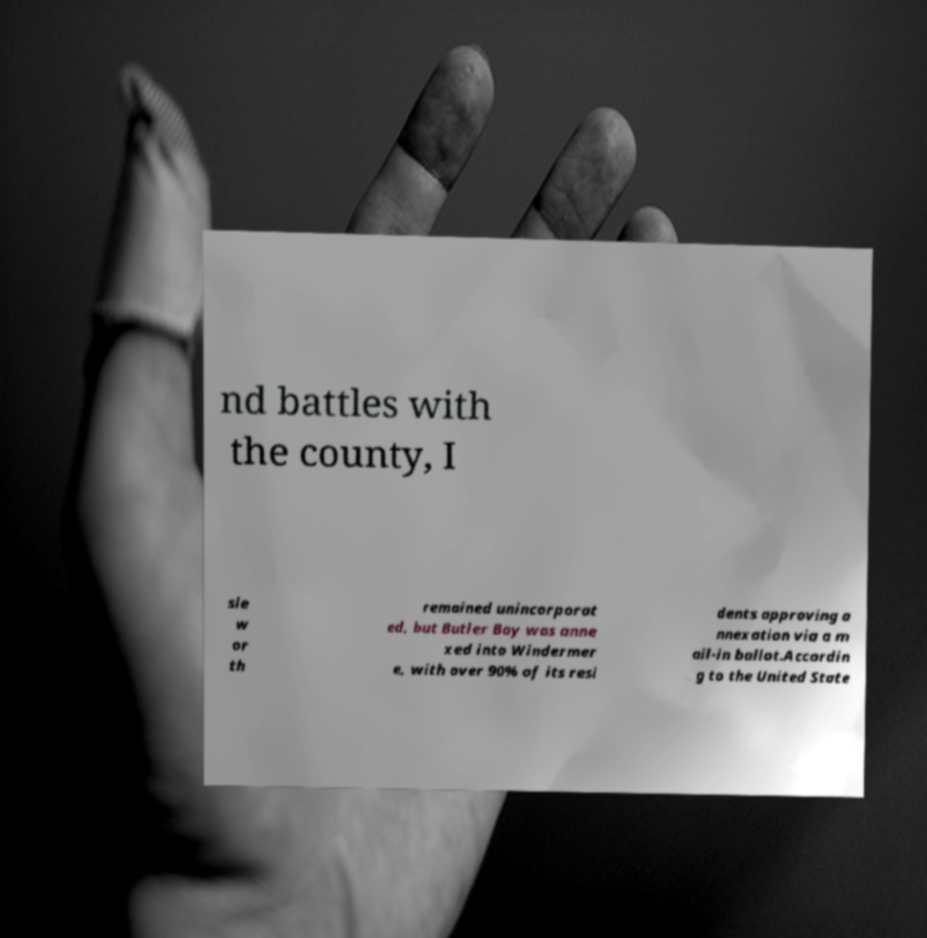Please read and relay the text visible in this image. What does it say? nd battles with the county, I sle w or th remained unincorporat ed, but Butler Bay was anne xed into Windermer e, with over 90% of its resi dents approving a nnexation via a m ail-in ballot.Accordin g to the United State 